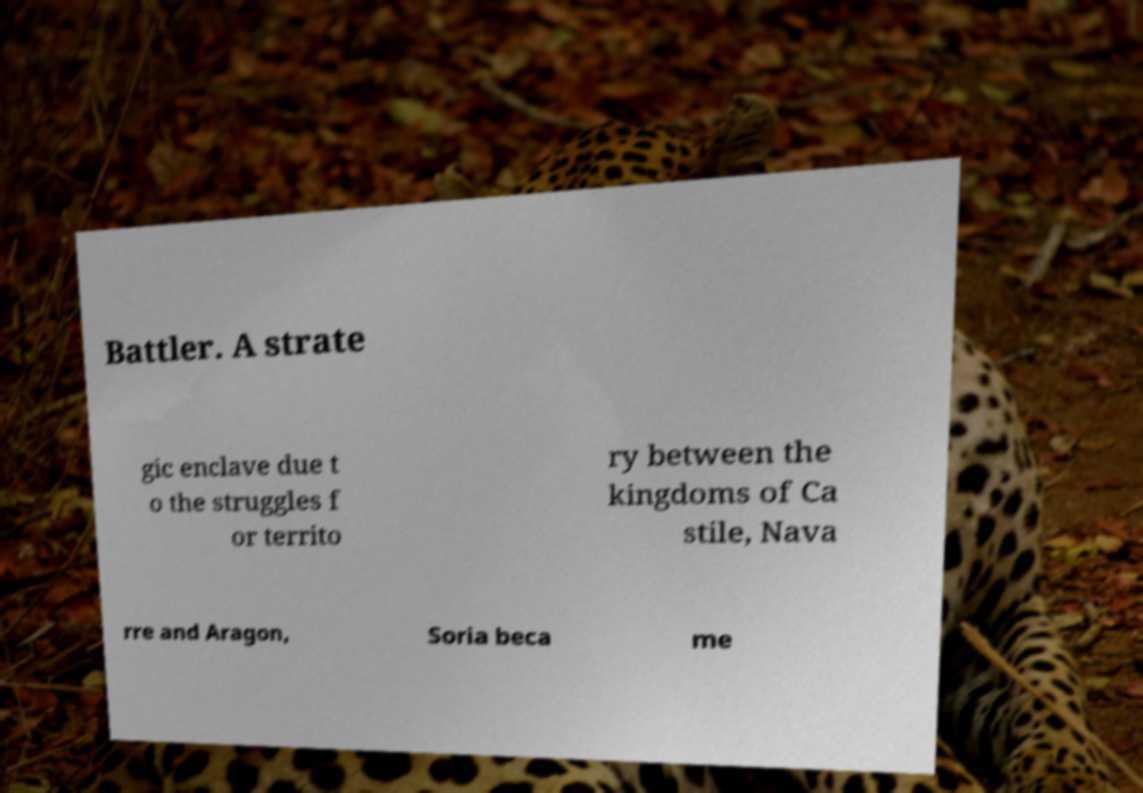Can you read and provide the text displayed in the image?This photo seems to have some interesting text. Can you extract and type it out for me? Battler. A strate gic enclave due t o the struggles f or territo ry between the kingdoms of Ca stile, Nava rre and Aragon, Soria beca me 